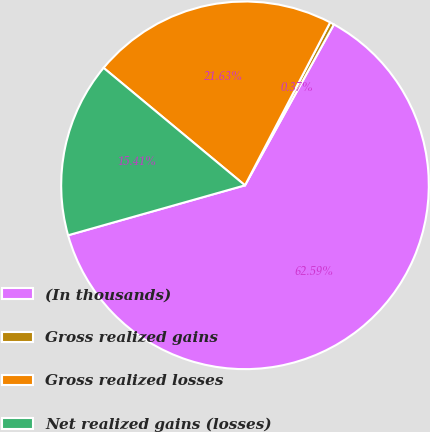<chart> <loc_0><loc_0><loc_500><loc_500><pie_chart><fcel>(In thousands)<fcel>Gross realized gains<fcel>Gross realized losses<fcel>Net realized gains (losses)<nl><fcel>62.58%<fcel>0.37%<fcel>21.63%<fcel>15.41%<nl></chart> 